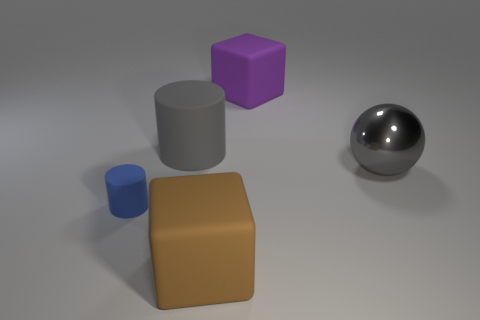There is a big object that is the same color as the big metallic ball; what is it made of?
Keep it short and to the point. Rubber. There is a gray object that is the same shape as the blue thing; what material is it?
Give a very brief answer. Rubber. Does the big gray object that is left of the gray metallic ball have the same shape as the tiny blue matte thing?
Your answer should be very brief. Yes. Is there anything else that is the same size as the blue rubber object?
Give a very brief answer. No. Are there fewer purple matte objects that are on the left side of the big purple rubber block than large matte cylinders that are left of the big gray metallic object?
Keep it short and to the point. Yes. What number of other things are the same shape as the big gray shiny thing?
Your answer should be compact. 0. How big is the block that is in front of the cube that is behind the large rubber block in front of the purple object?
Provide a short and direct response. Large. What number of brown things are either rubber objects or big metallic things?
Keep it short and to the point. 1. What shape is the object to the left of the rubber cylinder on the right side of the small cylinder?
Provide a short and direct response. Cylinder. There is a block that is on the right side of the brown thing; is its size the same as the cylinder behind the blue rubber cylinder?
Your answer should be compact. Yes. 